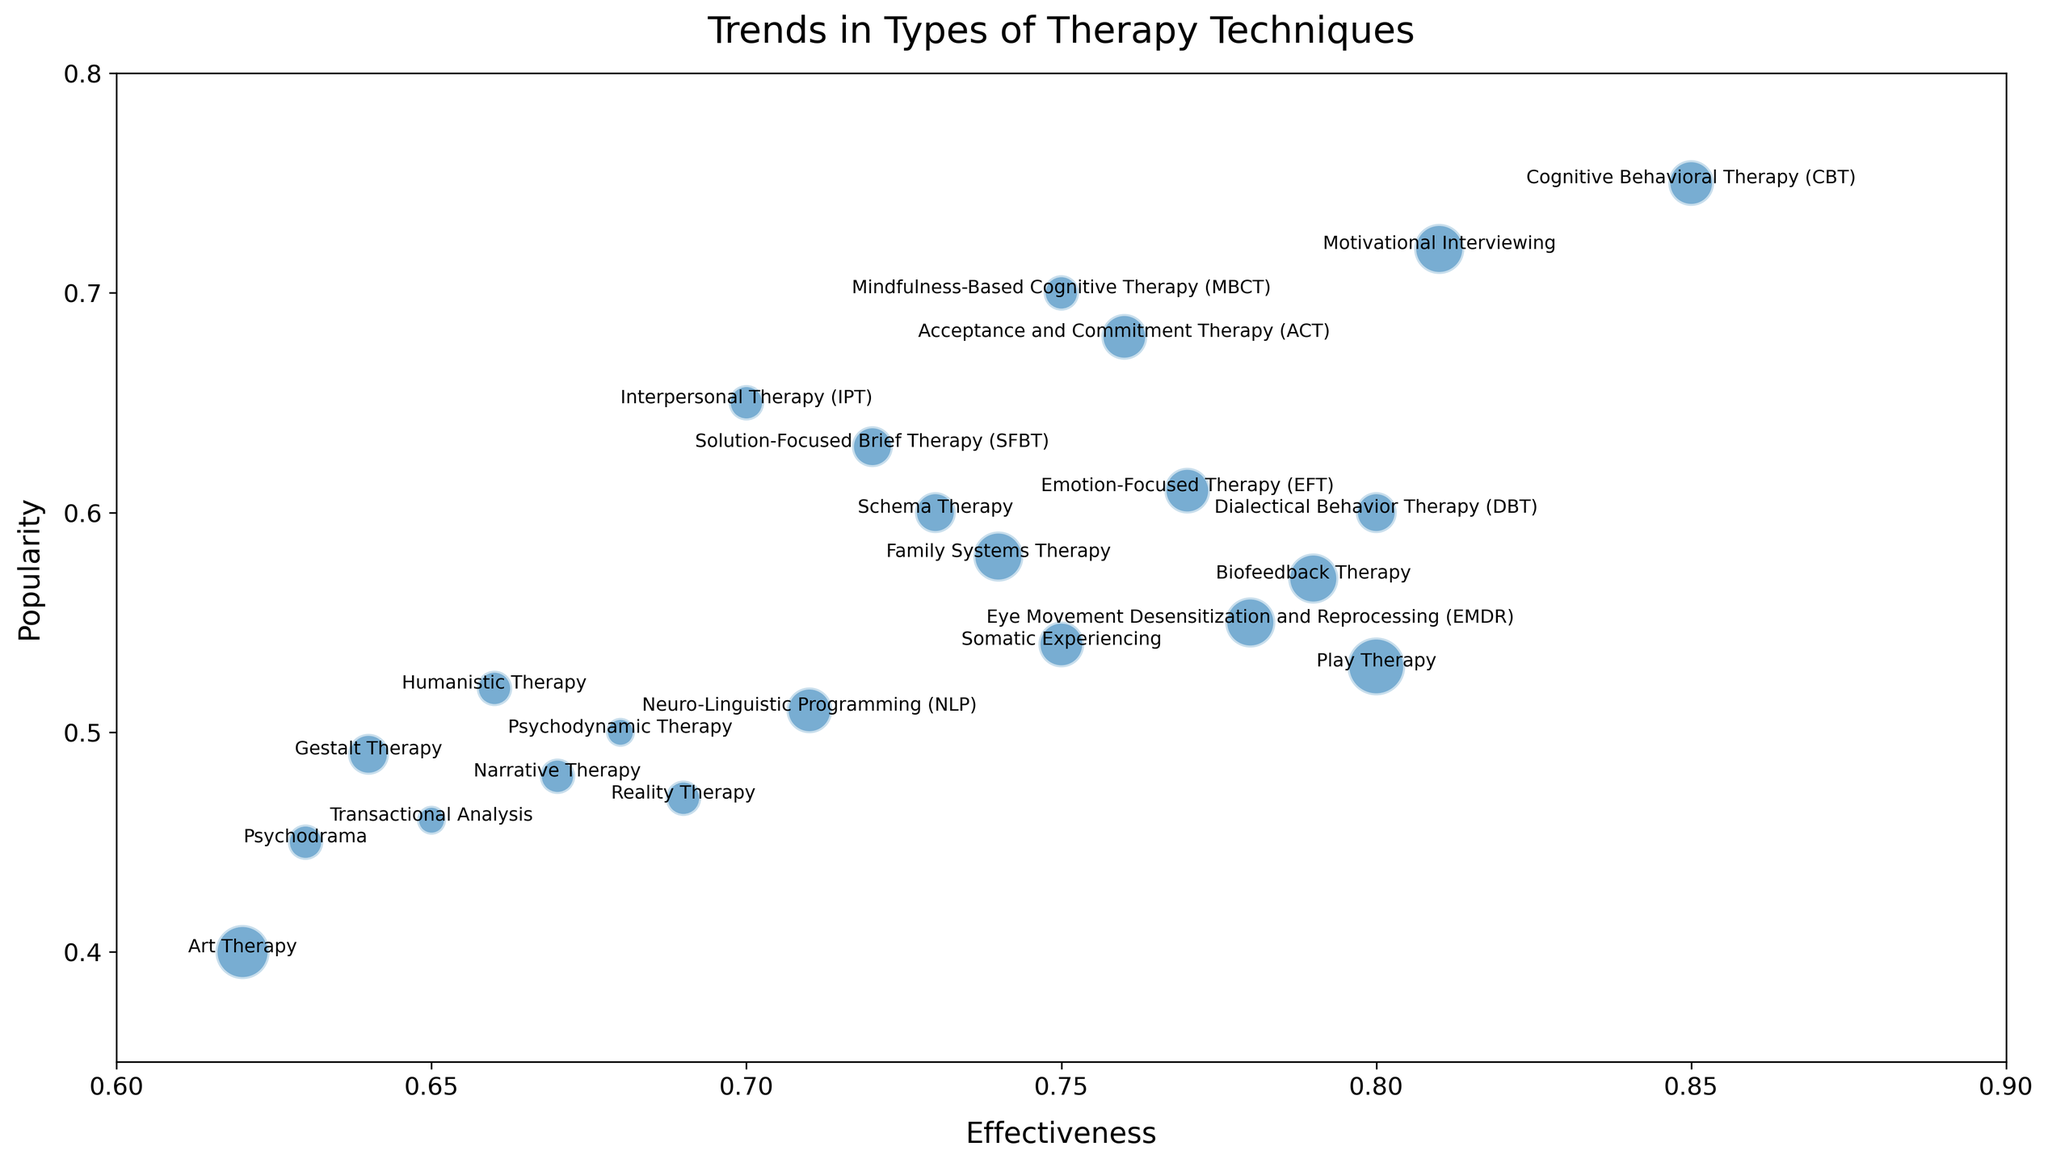What therapy technique has the highest combination of effectiveness and popularity? Identify the point that is highest in effectiveness and popularity. Cognitive Behavioral Therapy (CBT) has the highest combination of effectiveness (0.85) and popularity (0.75).
Answer: Cognitive Behavioral Therapy (CBT) Which therapy has a higher effectiveness, EMDR or DBT? Compare the effectiveness values of EMDR (0.78) and DBT (0.80). DBT has a slightly higher effectiveness.
Answer: DBT What is the average popularity of therapies with effectiveness above 0.75? Identify therapy techniques with effectiveness above 0.75: CBT (0.75), DBT (0.60), MBCT (0.70), EMDR (0.55), ACT (0.68), EFT (0.61), Motivational Interviewing (0.72), Biofeedback Therapy (0.57). Sum their popularity (0.75 + 0.60 + 0.70 + 0.55 + 0.68 + 0.61 + 0.72 + 0.57 = 5.18) and divide by number of therapies (8).
Answer: 0.65 Which therapy is the least popular? Identify the point with the lowest popularity value. Art Therapy has the lowest popularity (0.40).
Answer: Art Therapy Are there any therapies with equal levels of diversity? Look for therapies that have the same diversity value. No therapies have identical diversity levels.
Answer: No Which therapy technique has the largest bubble representing the highest diversity? Identify the largest bubble on the plot. Play Therapy has the largest bubble with the highest diversity value (0.8).
Answer: Play Therapy What is the difference in popularity between Motivational Interviewing and Biofeedback Therapy? Subtract Biofeedback Therapy's popularity (0.57) from Motivational Interviewing's popularity (0.72). (0.72 - 0.57 = 0.15)
Answer: 0.15 Determine the range of effectiveness values displayed in the plot. Determine the minimum and maximum values of effectiveness (0.62 to 0.85) and find the difference. (0.85 - 0.62 = 0.23)
Answer: 0.23 